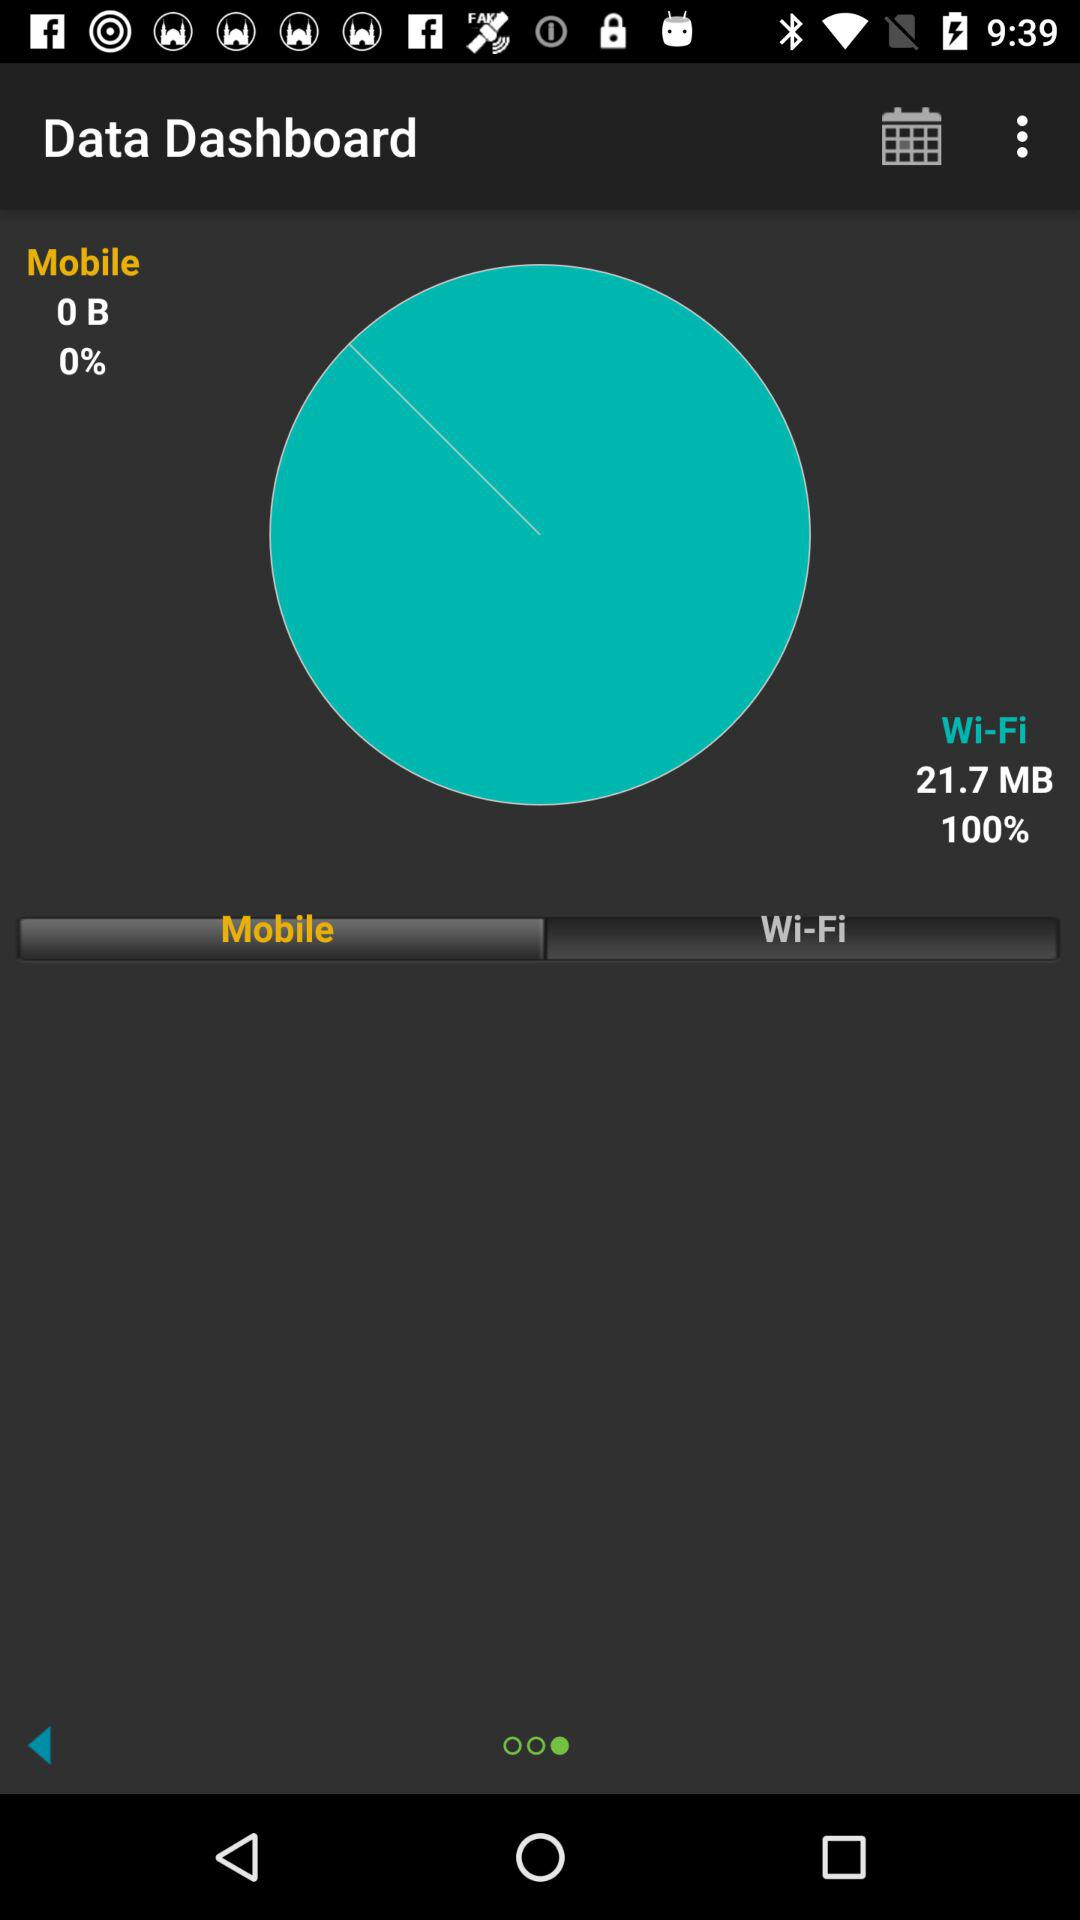How much mobile data has been used? The amount of mobile data that has been used is 0 B. 